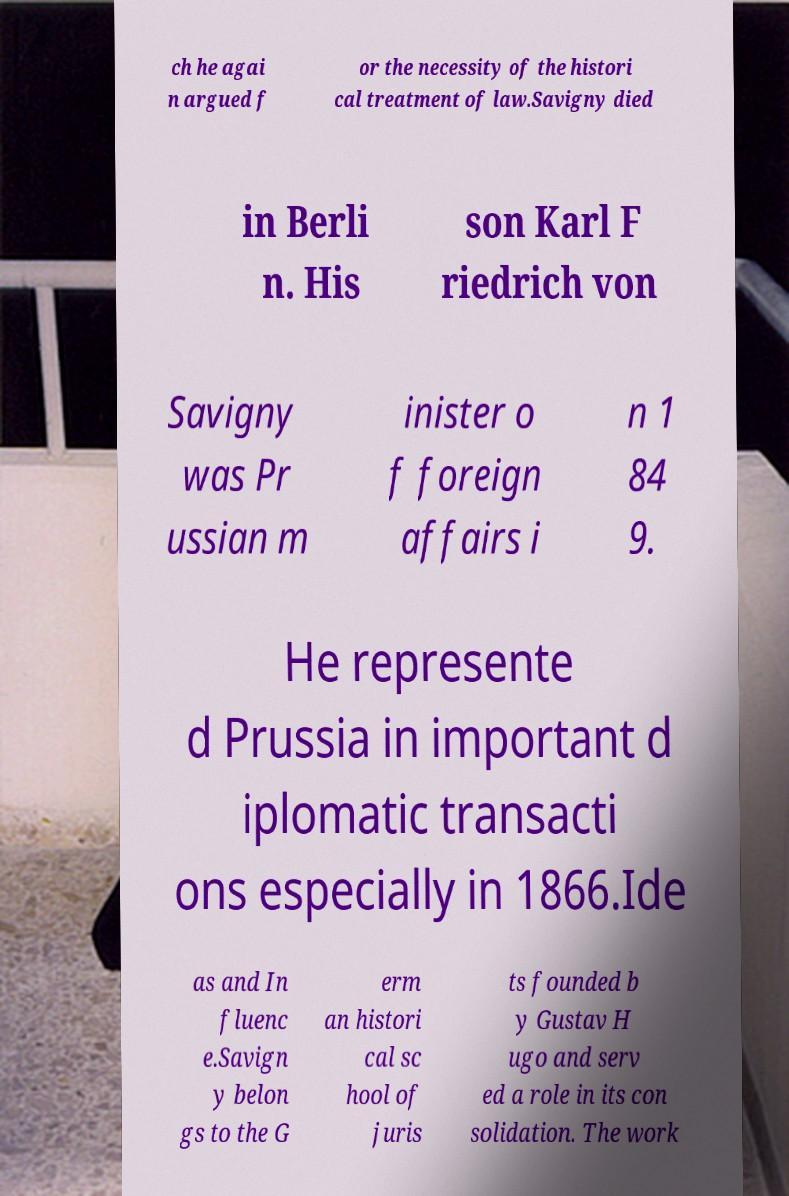There's text embedded in this image that I need extracted. Can you transcribe it verbatim? ch he agai n argued f or the necessity of the histori cal treatment of law.Savigny died in Berli n. His son Karl F riedrich von Savigny was Pr ussian m inister o f foreign affairs i n 1 84 9. He represente d Prussia in important d iplomatic transacti ons especially in 1866.Ide as and In fluenc e.Savign y belon gs to the G erm an histori cal sc hool of juris ts founded b y Gustav H ugo and serv ed a role in its con solidation. The work 